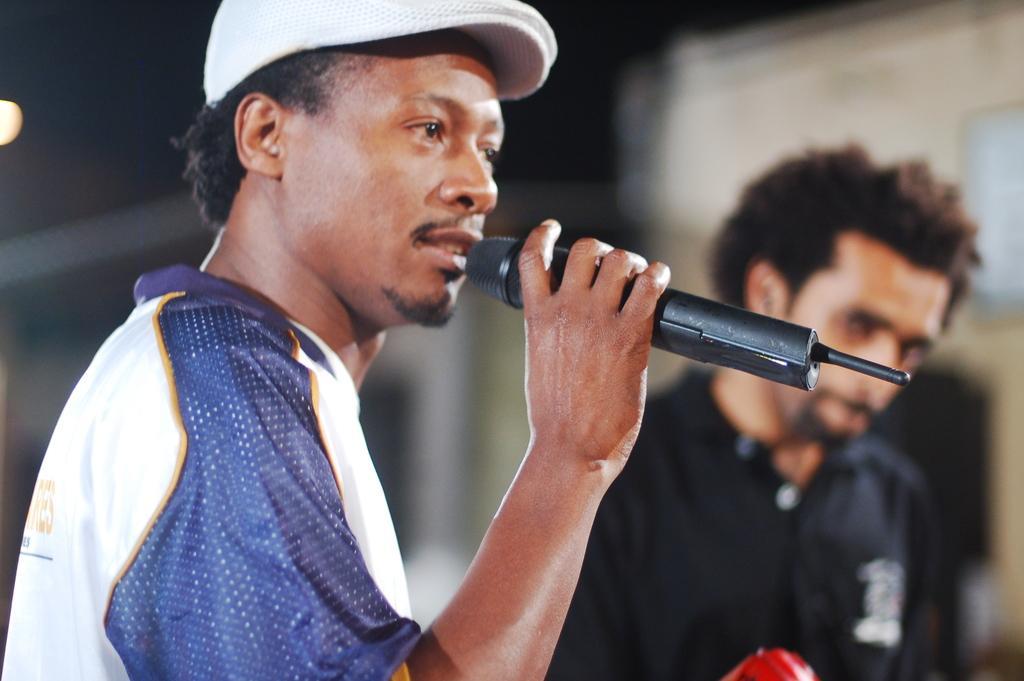Could you give a brief overview of what you see in this image? In this picture we can see two men where one is holding mic in his hand and talking and other is looking at this person and in background it is blurry. 